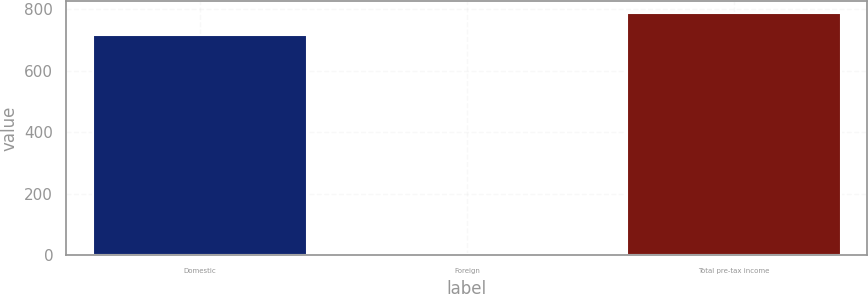<chart> <loc_0><loc_0><loc_500><loc_500><bar_chart><fcel>Domestic<fcel>Foreign<fcel>Total pre-tax income<nl><fcel>717.4<fcel>3.5<fcel>789.14<nl></chart> 